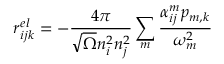Convert formula to latex. <formula><loc_0><loc_0><loc_500><loc_500>r _ { i j k } ^ { e l } = - \frac { 4 \pi } { \sqrt { \Omega } n _ { i } ^ { 2 } n _ { j } ^ { 2 } } \sum _ { m } \frac { \alpha _ { i j } ^ { m } p _ { m , k } } { \omega _ { m } ^ { 2 } }</formula> 